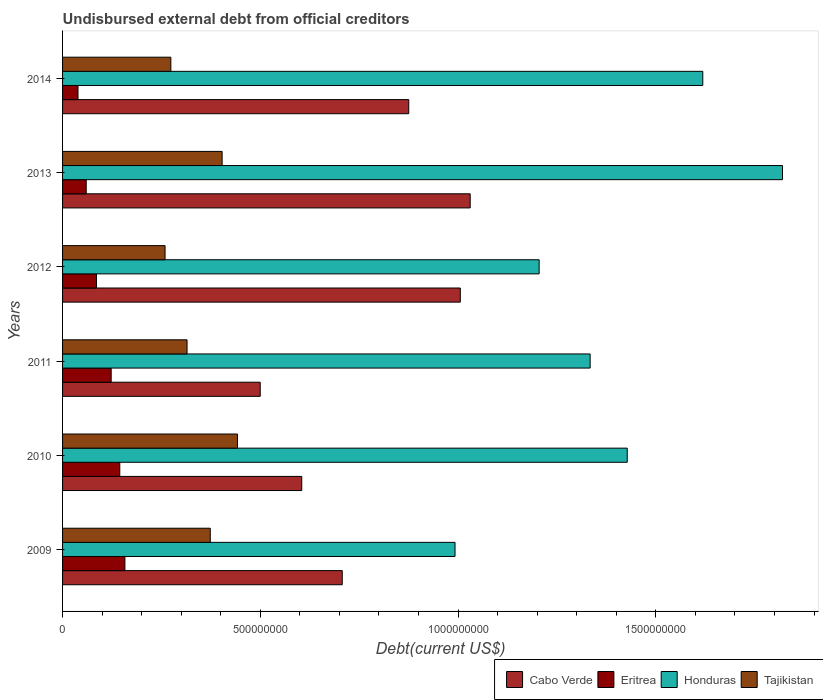Are the number of bars on each tick of the Y-axis equal?
Your response must be concise. Yes. How many bars are there on the 6th tick from the bottom?
Provide a short and direct response. 4. What is the label of the 4th group of bars from the top?
Keep it short and to the point. 2011. In how many cases, is the number of bars for a given year not equal to the number of legend labels?
Ensure brevity in your answer.  0. What is the total debt in Tajikistan in 2010?
Ensure brevity in your answer.  4.42e+08. Across all years, what is the maximum total debt in Cabo Verde?
Ensure brevity in your answer.  1.03e+09. Across all years, what is the minimum total debt in Eritrea?
Make the answer very short. 3.90e+07. In which year was the total debt in Eritrea maximum?
Give a very brief answer. 2009. In which year was the total debt in Cabo Verde minimum?
Offer a terse response. 2011. What is the total total debt in Honduras in the graph?
Offer a terse response. 8.40e+09. What is the difference between the total debt in Eritrea in 2011 and that in 2013?
Provide a short and direct response. 6.31e+07. What is the difference between the total debt in Eritrea in 2014 and the total debt in Tajikistan in 2012?
Your response must be concise. -2.20e+08. What is the average total debt in Eritrea per year?
Your answer should be very brief. 1.02e+08. In the year 2012, what is the difference between the total debt in Cabo Verde and total debt in Eritrea?
Ensure brevity in your answer.  9.20e+08. What is the ratio of the total debt in Eritrea in 2009 to that in 2012?
Provide a succinct answer. 1.84. Is the difference between the total debt in Cabo Verde in 2009 and 2011 greater than the difference between the total debt in Eritrea in 2009 and 2011?
Offer a terse response. Yes. What is the difference between the highest and the second highest total debt in Cabo Verde?
Your response must be concise. 2.50e+07. What is the difference between the highest and the lowest total debt in Honduras?
Make the answer very short. 8.28e+08. Is the sum of the total debt in Cabo Verde in 2010 and 2013 greater than the maximum total debt in Tajikistan across all years?
Ensure brevity in your answer.  Yes. Is it the case that in every year, the sum of the total debt in Eritrea and total debt in Honduras is greater than the sum of total debt in Tajikistan and total debt in Cabo Verde?
Keep it short and to the point. Yes. What does the 3rd bar from the top in 2011 represents?
Your response must be concise. Eritrea. What does the 4th bar from the bottom in 2011 represents?
Your answer should be very brief. Tajikistan. Is it the case that in every year, the sum of the total debt in Tajikistan and total debt in Eritrea is greater than the total debt in Honduras?
Keep it short and to the point. No. How many bars are there?
Provide a short and direct response. 24. Are all the bars in the graph horizontal?
Your answer should be very brief. Yes. Are the values on the major ticks of X-axis written in scientific E-notation?
Offer a terse response. No. Where does the legend appear in the graph?
Your response must be concise. Bottom right. How many legend labels are there?
Ensure brevity in your answer.  4. What is the title of the graph?
Offer a terse response. Undisbursed external debt from official creditors. What is the label or title of the X-axis?
Offer a terse response. Debt(current US$). What is the Debt(current US$) of Cabo Verde in 2009?
Your answer should be very brief. 7.07e+08. What is the Debt(current US$) of Eritrea in 2009?
Offer a very short reply. 1.58e+08. What is the Debt(current US$) of Honduras in 2009?
Keep it short and to the point. 9.92e+08. What is the Debt(current US$) of Tajikistan in 2009?
Make the answer very short. 3.73e+08. What is the Debt(current US$) of Cabo Verde in 2010?
Keep it short and to the point. 6.05e+08. What is the Debt(current US$) of Eritrea in 2010?
Provide a short and direct response. 1.45e+08. What is the Debt(current US$) in Honduras in 2010?
Provide a short and direct response. 1.43e+09. What is the Debt(current US$) in Tajikistan in 2010?
Make the answer very short. 4.42e+08. What is the Debt(current US$) of Cabo Verde in 2011?
Keep it short and to the point. 5.00e+08. What is the Debt(current US$) in Eritrea in 2011?
Your answer should be compact. 1.23e+08. What is the Debt(current US$) in Honduras in 2011?
Keep it short and to the point. 1.33e+09. What is the Debt(current US$) in Tajikistan in 2011?
Your response must be concise. 3.15e+08. What is the Debt(current US$) of Cabo Verde in 2012?
Your answer should be compact. 1.01e+09. What is the Debt(current US$) in Eritrea in 2012?
Provide a short and direct response. 8.58e+07. What is the Debt(current US$) in Honduras in 2012?
Your answer should be compact. 1.20e+09. What is the Debt(current US$) in Tajikistan in 2012?
Give a very brief answer. 2.59e+08. What is the Debt(current US$) of Cabo Verde in 2013?
Offer a very short reply. 1.03e+09. What is the Debt(current US$) of Eritrea in 2013?
Your answer should be compact. 5.98e+07. What is the Debt(current US$) of Honduras in 2013?
Your response must be concise. 1.82e+09. What is the Debt(current US$) of Tajikistan in 2013?
Give a very brief answer. 4.03e+08. What is the Debt(current US$) in Cabo Verde in 2014?
Ensure brevity in your answer.  8.75e+08. What is the Debt(current US$) of Eritrea in 2014?
Your answer should be compact. 3.90e+07. What is the Debt(current US$) in Honduras in 2014?
Give a very brief answer. 1.62e+09. What is the Debt(current US$) in Tajikistan in 2014?
Offer a very short reply. 2.74e+08. Across all years, what is the maximum Debt(current US$) in Cabo Verde?
Provide a short and direct response. 1.03e+09. Across all years, what is the maximum Debt(current US$) in Eritrea?
Ensure brevity in your answer.  1.58e+08. Across all years, what is the maximum Debt(current US$) of Honduras?
Provide a succinct answer. 1.82e+09. Across all years, what is the maximum Debt(current US$) in Tajikistan?
Make the answer very short. 4.42e+08. Across all years, what is the minimum Debt(current US$) in Cabo Verde?
Offer a very short reply. 5.00e+08. Across all years, what is the minimum Debt(current US$) in Eritrea?
Offer a very short reply. 3.90e+07. Across all years, what is the minimum Debt(current US$) of Honduras?
Ensure brevity in your answer.  9.92e+08. Across all years, what is the minimum Debt(current US$) in Tajikistan?
Provide a short and direct response. 2.59e+08. What is the total Debt(current US$) of Cabo Verde in the graph?
Your answer should be compact. 4.72e+09. What is the total Debt(current US$) in Eritrea in the graph?
Your response must be concise. 6.10e+08. What is the total Debt(current US$) of Honduras in the graph?
Keep it short and to the point. 8.40e+09. What is the total Debt(current US$) in Tajikistan in the graph?
Provide a succinct answer. 2.07e+09. What is the difference between the Debt(current US$) in Cabo Verde in 2009 and that in 2010?
Keep it short and to the point. 1.02e+08. What is the difference between the Debt(current US$) in Eritrea in 2009 and that in 2010?
Ensure brevity in your answer.  1.29e+07. What is the difference between the Debt(current US$) of Honduras in 2009 and that in 2010?
Your answer should be compact. -4.35e+08. What is the difference between the Debt(current US$) in Tajikistan in 2009 and that in 2010?
Your answer should be compact. -6.88e+07. What is the difference between the Debt(current US$) in Cabo Verde in 2009 and that in 2011?
Your answer should be very brief. 2.07e+08. What is the difference between the Debt(current US$) in Eritrea in 2009 and that in 2011?
Ensure brevity in your answer.  3.47e+07. What is the difference between the Debt(current US$) of Honduras in 2009 and that in 2011?
Ensure brevity in your answer.  -3.42e+08. What is the difference between the Debt(current US$) of Tajikistan in 2009 and that in 2011?
Ensure brevity in your answer.  5.87e+07. What is the difference between the Debt(current US$) of Cabo Verde in 2009 and that in 2012?
Offer a terse response. -2.99e+08. What is the difference between the Debt(current US$) in Eritrea in 2009 and that in 2012?
Keep it short and to the point. 7.18e+07. What is the difference between the Debt(current US$) of Honduras in 2009 and that in 2012?
Provide a succinct answer. -2.13e+08. What is the difference between the Debt(current US$) of Tajikistan in 2009 and that in 2012?
Ensure brevity in your answer.  1.14e+08. What is the difference between the Debt(current US$) of Cabo Verde in 2009 and that in 2013?
Offer a terse response. -3.23e+08. What is the difference between the Debt(current US$) of Eritrea in 2009 and that in 2013?
Keep it short and to the point. 9.78e+07. What is the difference between the Debt(current US$) in Honduras in 2009 and that in 2013?
Your answer should be compact. -8.28e+08. What is the difference between the Debt(current US$) in Tajikistan in 2009 and that in 2013?
Make the answer very short. -3.00e+07. What is the difference between the Debt(current US$) in Cabo Verde in 2009 and that in 2014?
Make the answer very short. -1.68e+08. What is the difference between the Debt(current US$) of Eritrea in 2009 and that in 2014?
Offer a very short reply. 1.19e+08. What is the difference between the Debt(current US$) of Honduras in 2009 and that in 2014?
Ensure brevity in your answer.  -6.26e+08. What is the difference between the Debt(current US$) in Tajikistan in 2009 and that in 2014?
Make the answer very short. 9.97e+07. What is the difference between the Debt(current US$) in Cabo Verde in 2010 and that in 2011?
Offer a terse response. 1.05e+08. What is the difference between the Debt(current US$) of Eritrea in 2010 and that in 2011?
Your answer should be very brief. 2.18e+07. What is the difference between the Debt(current US$) in Honduras in 2010 and that in 2011?
Your answer should be very brief. 9.38e+07. What is the difference between the Debt(current US$) of Tajikistan in 2010 and that in 2011?
Offer a terse response. 1.27e+08. What is the difference between the Debt(current US$) in Cabo Verde in 2010 and that in 2012?
Your answer should be compact. -4.01e+08. What is the difference between the Debt(current US$) in Eritrea in 2010 and that in 2012?
Give a very brief answer. 5.89e+07. What is the difference between the Debt(current US$) of Honduras in 2010 and that in 2012?
Your answer should be compact. 2.23e+08. What is the difference between the Debt(current US$) of Tajikistan in 2010 and that in 2012?
Your response must be concise. 1.83e+08. What is the difference between the Debt(current US$) in Cabo Verde in 2010 and that in 2013?
Offer a terse response. -4.26e+08. What is the difference between the Debt(current US$) in Eritrea in 2010 and that in 2013?
Offer a very short reply. 8.49e+07. What is the difference between the Debt(current US$) in Honduras in 2010 and that in 2013?
Give a very brief answer. -3.93e+08. What is the difference between the Debt(current US$) of Tajikistan in 2010 and that in 2013?
Your answer should be very brief. 3.88e+07. What is the difference between the Debt(current US$) of Cabo Verde in 2010 and that in 2014?
Your answer should be very brief. -2.71e+08. What is the difference between the Debt(current US$) of Eritrea in 2010 and that in 2014?
Give a very brief answer. 1.06e+08. What is the difference between the Debt(current US$) in Honduras in 2010 and that in 2014?
Keep it short and to the point. -1.91e+08. What is the difference between the Debt(current US$) in Tajikistan in 2010 and that in 2014?
Make the answer very short. 1.68e+08. What is the difference between the Debt(current US$) in Cabo Verde in 2011 and that in 2012?
Offer a very short reply. -5.06e+08. What is the difference between the Debt(current US$) in Eritrea in 2011 and that in 2012?
Offer a very short reply. 3.71e+07. What is the difference between the Debt(current US$) of Honduras in 2011 and that in 2012?
Keep it short and to the point. 1.29e+08. What is the difference between the Debt(current US$) in Tajikistan in 2011 and that in 2012?
Offer a very short reply. 5.56e+07. What is the difference between the Debt(current US$) in Cabo Verde in 2011 and that in 2013?
Keep it short and to the point. -5.31e+08. What is the difference between the Debt(current US$) of Eritrea in 2011 and that in 2013?
Ensure brevity in your answer.  6.31e+07. What is the difference between the Debt(current US$) in Honduras in 2011 and that in 2013?
Provide a short and direct response. -4.86e+08. What is the difference between the Debt(current US$) of Tajikistan in 2011 and that in 2013?
Keep it short and to the point. -8.87e+07. What is the difference between the Debt(current US$) in Cabo Verde in 2011 and that in 2014?
Provide a succinct answer. -3.76e+08. What is the difference between the Debt(current US$) of Eritrea in 2011 and that in 2014?
Offer a very short reply. 8.38e+07. What is the difference between the Debt(current US$) in Honduras in 2011 and that in 2014?
Provide a short and direct response. -2.85e+08. What is the difference between the Debt(current US$) in Tajikistan in 2011 and that in 2014?
Your answer should be compact. 4.10e+07. What is the difference between the Debt(current US$) in Cabo Verde in 2012 and that in 2013?
Keep it short and to the point. -2.50e+07. What is the difference between the Debt(current US$) in Eritrea in 2012 and that in 2013?
Keep it short and to the point. 2.60e+07. What is the difference between the Debt(current US$) in Honduras in 2012 and that in 2013?
Provide a short and direct response. -6.15e+08. What is the difference between the Debt(current US$) of Tajikistan in 2012 and that in 2013?
Provide a succinct answer. -1.44e+08. What is the difference between the Debt(current US$) of Cabo Verde in 2012 and that in 2014?
Make the answer very short. 1.30e+08. What is the difference between the Debt(current US$) in Eritrea in 2012 and that in 2014?
Your response must be concise. 4.68e+07. What is the difference between the Debt(current US$) of Honduras in 2012 and that in 2014?
Your answer should be very brief. -4.14e+08. What is the difference between the Debt(current US$) in Tajikistan in 2012 and that in 2014?
Provide a succinct answer. -1.46e+07. What is the difference between the Debt(current US$) in Cabo Verde in 2013 and that in 2014?
Offer a terse response. 1.55e+08. What is the difference between the Debt(current US$) of Eritrea in 2013 and that in 2014?
Your response must be concise. 2.08e+07. What is the difference between the Debt(current US$) of Honduras in 2013 and that in 2014?
Your response must be concise. 2.02e+08. What is the difference between the Debt(current US$) of Tajikistan in 2013 and that in 2014?
Keep it short and to the point. 1.30e+08. What is the difference between the Debt(current US$) of Cabo Verde in 2009 and the Debt(current US$) of Eritrea in 2010?
Make the answer very short. 5.62e+08. What is the difference between the Debt(current US$) of Cabo Verde in 2009 and the Debt(current US$) of Honduras in 2010?
Your response must be concise. -7.21e+08. What is the difference between the Debt(current US$) in Cabo Verde in 2009 and the Debt(current US$) in Tajikistan in 2010?
Provide a short and direct response. 2.65e+08. What is the difference between the Debt(current US$) of Eritrea in 2009 and the Debt(current US$) of Honduras in 2010?
Provide a short and direct response. -1.27e+09. What is the difference between the Debt(current US$) in Eritrea in 2009 and the Debt(current US$) in Tajikistan in 2010?
Offer a terse response. -2.85e+08. What is the difference between the Debt(current US$) of Honduras in 2009 and the Debt(current US$) of Tajikistan in 2010?
Your answer should be very brief. 5.50e+08. What is the difference between the Debt(current US$) in Cabo Verde in 2009 and the Debt(current US$) in Eritrea in 2011?
Ensure brevity in your answer.  5.84e+08. What is the difference between the Debt(current US$) in Cabo Verde in 2009 and the Debt(current US$) in Honduras in 2011?
Offer a terse response. -6.27e+08. What is the difference between the Debt(current US$) in Cabo Verde in 2009 and the Debt(current US$) in Tajikistan in 2011?
Offer a terse response. 3.92e+08. What is the difference between the Debt(current US$) of Eritrea in 2009 and the Debt(current US$) of Honduras in 2011?
Give a very brief answer. -1.18e+09. What is the difference between the Debt(current US$) of Eritrea in 2009 and the Debt(current US$) of Tajikistan in 2011?
Your answer should be compact. -1.57e+08. What is the difference between the Debt(current US$) in Honduras in 2009 and the Debt(current US$) in Tajikistan in 2011?
Your answer should be compact. 6.78e+08. What is the difference between the Debt(current US$) of Cabo Verde in 2009 and the Debt(current US$) of Eritrea in 2012?
Ensure brevity in your answer.  6.21e+08. What is the difference between the Debt(current US$) of Cabo Verde in 2009 and the Debt(current US$) of Honduras in 2012?
Ensure brevity in your answer.  -4.98e+08. What is the difference between the Debt(current US$) in Cabo Verde in 2009 and the Debt(current US$) in Tajikistan in 2012?
Offer a terse response. 4.48e+08. What is the difference between the Debt(current US$) of Eritrea in 2009 and the Debt(current US$) of Honduras in 2012?
Offer a very short reply. -1.05e+09. What is the difference between the Debt(current US$) of Eritrea in 2009 and the Debt(current US$) of Tajikistan in 2012?
Your response must be concise. -1.02e+08. What is the difference between the Debt(current US$) in Honduras in 2009 and the Debt(current US$) in Tajikistan in 2012?
Make the answer very short. 7.33e+08. What is the difference between the Debt(current US$) of Cabo Verde in 2009 and the Debt(current US$) of Eritrea in 2013?
Your response must be concise. 6.47e+08. What is the difference between the Debt(current US$) of Cabo Verde in 2009 and the Debt(current US$) of Honduras in 2013?
Your answer should be compact. -1.11e+09. What is the difference between the Debt(current US$) of Cabo Verde in 2009 and the Debt(current US$) of Tajikistan in 2013?
Give a very brief answer. 3.04e+08. What is the difference between the Debt(current US$) of Eritrea in 2009 and the Debt(current US$) of Honduras in 2013?
Give a very brief answer. -1.66e+09. What is the difference between the Debt(current US$) of Eritrea in 2009 and the Debt(current US$) of Tajikistan in 2013?
Give a very brief answer. -2.46e+08. What is the difference between the Debt(current US$) of Honduras in 2009 and the Debt(current US$) of Tajikistan in 2013?
Offer a terse response. 5.89e+08. What is the difference between the Debt(current US$) in Cabo Verde in 2009 and the Debt(current US$) in Eritrea in 2014?
Your answer should be compact. 6.68e+08. What is the difference between the Debt(current US$) of Cabo Verde in 2009 and the Debt(current US$) of Honduras in 2014?
Ensure brevity in your answer.  -9.12e+08. What is the difference between the Debt(current US$) in Cabo Verde in 2009 and the Debt(current US$) in Tajikistan in 2014?
Offer a terse response. 4.33e+08. What is the difference between the Debt(current US$) in Eritrea in 2009 and the Debt(current US$) in Honduras in 2014?
Your answer should be very brief. -1.46e+09. What is the difference between the Debt(current US$) in Eritrea in 2009 and the Debt(current US$) in Tajikistan in 2014?
Give a very brief answer. -1.16e+08. What is the difference between the Debt(current US$) of Honduras in 2009 and the Debt(current US$) of Tajikistan in 2014?
Give a very brief answer. 7.19e+08. What is the difference between the Debt(current US$) of Cabo Verde in 2010 and the Debt(current US$) of Eritrea in 2011?
Offer a terse response. 4.82e+08. What is the difference between the Debt(current US$) in Cabo Verde in 2010 and the Debt(current US$) in Honduras in 2011?
Your response must be concise. -7.29e+08. What is the difference between the Debt(current US$) of Cabo Verde in 2010 and the Debt(current US$) of Tajikistan in 2011?
Offer a very short reply. 2.90e+08. What is the difference between the Debt(current US$) in Eritrea in 2010 and the Debt(current US$) in Honduras in 2011?
Provide a succinct answer. -1.19e+09. What is the difference between the Debt(current US$) of Eritrea in 2010 and the Debt(current US$) of Tajikistan in 2011?
Your answer should be compact. -1.70e+08. What is the difference between the Debt(current US$) of Honduras in 2010 and the Debt(current US$) of Tajikistan in 2011?
Make the answer very short. 1.11e+09. What is the difference between the Debt(current US$) of Cabo Verde in 2010 and the Debt(current US$) of Eritrea in 2012?
Offer a very short reply. 5.19e+08. What is the difference between the Debt(current US$) of Cabo Verde in 2010 and the Debt(current US$) of Honduras in 2012?
Ensure brevity in your answer.  -6.00e+08. What is the difference between the Debt(current US$) of Cabo Verde in 2010 and the Debt(current US$) of Tajikistan in 2012?
Offer a terse response. 3.46e+08. What is the difference between the Debt(current US$) of Eritrea in 2010 and the Debt(current US$) of Honduras in 2012?
Give a very brief answer. -1.06e+09. What is the difference between the Debt(current US$) in Eritrea in 2010 and the Debt(current US$) in Tajikistan in 2012?
Offer a terse response. -1.14e+08. What is the difference between the Debt(current US$) in Honduras in 2010 and the Debt(current US$) in Tajikistan in 2012?
Keep it short and to the point. 1.17e+09. What is the difference between the Debt(current US$) of Cabo Verde in 2010 and the Debt(current US$) of Eritrea in 2013?
Make the answer very short. 5.45e+08. What is the difference between the Debt(current US$) of Cabo Verde in 2010 and the Debt(current US$) of Honduras in 2013?
Make the answer very short. -1.22e+09. What is the difference between the Debt(current US$) of Cabo Verde in 2010 and the Debt(current US$) of Tajikistan in 2013?
Your answer should be compact. 2.01e+08. What is the difference between the Debt(current US$) of Eritrea in 2010 and the Debt(current US$) of Honduras in 2013?
Provide a succinct answer. -1.68e+09. What is the difference between the Debt(current US$) in Eritrea in 2010 and the Debt(current US$) in Tajikistan in 2013?
Offer a terse response. -2.59e+08. What is the difference between the Debt(current US$) in Honduras in 2010 and the Debt(current US$) in Tajikistan in 2013?
Offer a terse response. 1.02e+09. What is the difference between the Debt(current US$) of Cabo Verde in 2010 and the Debt(current US$) of Eritrea in 2014?
Make the answer very short. 5.66e+08. What is the difference between the Debt(current US$) of Cabo Verde in 2010 and the Debt(current US$) of Honduras in 2014?
Provide a short and direct response. -1.01e+09. What is the difference between the Debt(current US$) in Cabo Verde in 2010 and the Debt(current US$) in Tajikistan in 2014?
Ensure brevity in your answer.  3.31e+08. What is the difference between the Debt(current US$) in Eritrea in 2010 and the Debt(current US$) in Honduras in 2014?
Ensure brevity in your answer.  -1.47e+09. What is the difference between the Debt(current US$) in Eritrea in 2010 and the Debt(current US$) in Tajikistan in 2014?
Ensure brevity in your answer.  -1.29e+08. What is the difference between the Debt(current US$) in Honduras in 2010 and the Debt(current US$) in Tajikistan in 2014?
Offer a very short reply. 1.15e+09. What is the difference between the Debt(current US$) in Cabo Verde in 2011 and the Debt(current US$) in Eritrea in 2012?
Offer a terse response. 4.14e+08. What is the difference between the Debt(current US$) in Cabo Verde in 2011 and the Debt(current US$) in Honduras in 2012?
Offer a very short reply. -7.05e+08. What is the difference between the Debt(current US$) in Cabo Verde in 2011 and the Debt(current US$) in Tajikistan in 2012?
Offer a terse response. 2.41e+08. What is the difference between the Debt(current US$) of Eritrea in 2011 and the Debt(current US$) of Honduras in 2012?
Offer a very short reply. -1.08e+09. What is the difference between the Debt(current US$) of Eritrea in 2011 and the Debt(current US$) of Tajikistan in 2012?
Your response must be concise. -1.36e+08. What is the difference between the Debt(current US$) in Honduras in 2011 and the Debt(current US$) in Tajikistan in 2012?
Provide a short and direct response. 1.07e+09. What is the difference between the Debt(current US$) of Cabo Verde in 2011 and the Debt(current US$) of Eritrea in 2013?
Provide a short and direct response. 4.40e+08. What is the difference between the Debt(current US$) of Cabo Verde in 2011 and the Debt(current US$) of Honduras in 2013?
Provide a short and direct response. -1.32e+09. What is the difference between the Debt(current US$) in Cabo Verde in 2011 and the Debt(current US$) in Tajikistan in 2013?
Ensure brevity in your answer.  9.63e+07. What is the difference between the Debt(current US$) of Eritrea in 2011 and the Debt(current US$) of Honduras in 2013?
Provide a short and direct response. -1.70e+09. What is the difference between the Debt(current US$) in Eritrea in 2011 and the Debt(current US$) in Tajikistan in 2013?
Provide a succinct answer. -2.81e+08. What is the difference between the Debt(current US$) of Honduras in 2011 and the Debt(current US$) of Tajikistan in 2013?
Offer a very short reply. 9.30e+08. What is the difference between the Debt(current US$) in Cabo Verde in 2011 and the Debt(current US$) in Eritrea in 2014?
Offer a very short reply. 4.61e+08. What is the difference between the Debt(current US$) of Cabo Verde in 2011 and the Debt(current US$) of Honduras in 2014?
Provide a succinct answer. -1.12e+09. What is the difference between the Debt(current US$) of Cabo Verde in 2011 and the Debt(current US$) of Tajikistan in 2014?
Give a very brief answer. 2.26e+08. What is the difference between the Debt(current US$) in Eritrea in 2011 and the Debt(current US$) in Honduras in 2014?
Keep it short and to the point. -1.50e+09. What is the difference between the Debt(current US$) of Eritrea in 2011 and the Debt(current US$) of Tajikistan in 2014?
Offer a very short reply. -1.51e+08. What is the difference between the Debt(current US$) of Honduras in 2011 and the Debt(current US$) of Tajikistan in 2014?
Your answer should be very brief. 1.06e+09. What is the difference between the Debt(current US$) of Cabo Verde in 2012 and the Debt(current US$) of Eritrea in 2013?
Your answer should be very brief. 9.46e+08. What is the difference between the Debt(current US$) in Cabo Verde in 2012 and the Debt(current US$) in Honduras in 2013?
Make the answer very short. -8.15e+08. What is the difference between the Debt(current US$) of Cabo Verde in 2012 and the Debt(current US$) of Tajikistan in 2013?
Your response must be concise. 6.02e+08. What is the difference between the Debt(current US$) of Eritrea in 2012 and the Debt(current US$) of Honduras in 2013?
Your answer should be very brief. -1.73e+09. What is the difference between the Debt(current US$) of Eritrea in 2012 and the Debt(current US$) of Tajikistan in 2013?
Your answer should be very brief. -3.18e+08. What is the difference between the Debt(current US$) of Honduras in 2012 and the Debt(current US$) of Tajikistan in 2013?
Make the answer very short. 8.02e+08. What is the difference between the Debt(current US$) of Cabo Verde in 2012 and the Debt(current US$) of Eritrea in 2014?
Keep it short and to the point. 9.67e+08. What is the difference between the Debt(current US$) in Cabo Verde in 2012 and the Debt(current US$) in Honduras in 2014?
Offer a terse response. -6.13e+08. What is the difference between the Debt(current US$) of Cabo Verde in 2012 and the Debt(current US$) of Tajikistan in 2014?
Offer a terse response. 7.32e+08. What is the difference between the Debt(current US$) of Eritrea in 2012 and the Debt(current US$) of Honduras in 2014?
Offer a very short reply. -1.53e+09. What is the difference between the Debt(current US$) of Eritrea in 2012 and the Debt(current US$) of Tajikistan in 2014?
Offer a terse response. -1.88e+08. What is the difference between the Debt(current US$) in Honduras in 2012 and the Debt(current US$) in Tajikistan in 2014?
Your answer should be compact. 9.31e+08. What is the difference between the Debt(current US$) of Cabo Verde in 2013 and the Debt(current US$) of Eritrea in 2014?
Keep it short and to the point. 9.92e+08. What is the difference between the Debt(current US$) in Cabo Verde in 2013 and the Debt(current US$) in Honduras in 2014?
Ensure brevity in your answer.  -5.88e+08. What is the difference between the Debt(current US$) in Cabo Verde in 2013 and the Debt(current US$) in Tajikistan in 2014?
Provide a succinct answer. 7.57e+08. What is the difference between the Debt(current US$) of Eritrea in 2013 and the Debt(current US$) of Honduras in 2014?
Make the answer very short. -1.56e+09. What is the difference between the Debt(current US$) of Eritrea in 2013 and the Debt(current US$) of Tajikistan in 2014?
Provide a short and direct response. -2.14e+08. What is the difference between the Debt(current US$) of Honduras in 2013 and the Debt(current US$) of Tajikistan in 2014?
Provide a short and direct response. 1.55e+09. What is the average Debt(current US$) in Cabo Verde per year?
Provide a succinct answer. 7.87e+08. What is the average Debt(current US$) in Eritrea per year?
Give a very brief answer. 1.02e+08. What is the average Debt(current US$) in Honduras per year?
Provide a short and direct response. 1.40e+09. What is the average Debt(current US$) in Tajikistan per year?
Your response must be concise. 3.44e+08. In the year 2009, what is the difference between the Debt(current US$) of Cabo Verde and Debt(current US$) of Eritrea?
Offer a terse response. 5.50e+08. In the year 2009, what is the difference between the Debt(current US$) of Cabo Verde and Debt(current US$) of Honduras?
Your response must be concise. -2.85e+08. In the year 2009, what is the difference between the Debt(current US$) of Cabo Verde and Debt(current US$) of Tajikistan?
Keep it short and to the point. 3.34e+08. In the year 2009, what is the difference between the Debt(current US$) of Eritrea and Debt(current US$) of Honduras?
Your answer should be very brief. -8.35e+08. In the year 2009, what is the difference between the Debt(current US$) in Eritrea and Debt(current US$) in Tajikistan?
Give a very brief answer. -2.16e+08. In the year 2009, what is the difference between the Debt(current US$) in Honduras and Debt(current US$) in Tajikistan?
Keep it short and to the point. 6.19e+08. In the year 2010, what is the difference between the Debt(current US$) of Cabo Verde and Debt(current US$) of Eritrea?
Offer a terse response. 4.60e+08. In the year 2010, what is the difference between the Debt(current US$) of Cabo Verde and Debt(current US$) of Honduras?
Ensure brevity in your answer.  -8.23e+08. In the year 2010, what is the difference between the Debt(current US$) of Cabo Verde and Debt(current US$) of Tajikistan?
Your response must be concise. 1.63e+08. In the year 2010, what is the difference between the Debt(current US$) in Eritrea and Debt(current US$) in Honduras?
Offer a very short reply. -1.28e+09. In the year 2010, what is the difference between the Debt(current US$) in Eritrea and Debt(current US$) in Tajikistan?
Give a very brief answer. -2.98e+08. In the year 2010, what is the difference between the Debt(current US$) of Honduras and Debt(current US$) of Tajikistan?
Your response must be concise. 9.85e+08. In the year 2011, what is the difference between the Debt(current US$) of Cabo Verde and Debt(current US$) of Eritrea?
Keep it short and to the point. 3.77e+08. In the year 2011, what is the difference between the Debt(current US$) in Cabo Verde and Debt(current US$) in Honduras?
Your answer should be compact. -8.34e+08. In the year 2011, what is the difference between the Debt(current US$) in Cabo Verde and Debt(current US$) in Tajikistan?
Keep it short and to the point. 1.85e+08. In the year 2011, what is the difference between the Debt(current US$) in Eritrea and Debt(current US$) in Honduras?
Your answer should be very brief. -1.21e+09. In the year 2011, what is the difference between the Debt(current US$) in Eritrea and Debt(current US$) in Tajikistan?
Offer a terse response. -1.92e+08. In the year 2011, what is the difference between the Debt(current US$) of Honduras and Debt(current US$) of Tajikistan?
Make the answer very short. 1.02e+09. In the year 2012, what is the difference between the Debt(current US$) in Cabo Verde and Debt(current US$) in Eritrea?
Your response must be concise. 9.20e+08. In the year 2012, what is the difference between the Debt(current US$) in Cabo Verde and Debt(current US$) in Honduras?
Offer a terse response. -1.99e+08. In the year 2012, what is the difference between the Debt(current US$) in Cabo Verde and Debt(current US$) in Tajikistan?
Provide a short and direct response. 7.47e+08. In the year 2012, what is the difference between the Debt(current US$) in Eritrea and Debt(current US$) in Honduras?
Provide a short and direct response. -1.12e+09. In the year 2012, what is the difference between the Debt(current US$) of Eritrea and Debt(current US$) of Tajikistan?
Keep it short and to the point. -1.73e+08. In the year 2012, what is the difference between the Debt(current US$) in Honduras and Debt(current US$) in Tajikistan?
Your answer should be very brief. 9.46e+08. In the year 2013, what is the difference between the Debt(current US$) of Cabo Verde and Debt(current US$) of Eritrea?
Ensure brevity in your answer.  9.71e+08. In the year 2013, what is the difference between the Debt(current US$) of Cabo Verde and Debt(current US$) of Honduras?
Offer a terse response. -7.90e+08. In the year 2013, what is the difference between the Debt(current US$) of Cabo Verde and Debt(current US$) of Tajikistan?
Make the answer very short. 6.27e+08. In the year 2013, what is the difference between the Debt(current US$) in Eritrea and Debt(current US$) in Honduras?
Ensure brevity in your answer.  -1.76e+09. In the year 2013, what is the difference between the Debt(current US$) of Eritrea and Debt(current US$) of Tajikistan?
Your answer should be compact. -3.44e+08. In the year 2013, what is the difference between the Debt(current US$) in Honduras and Debt(current US$) in Tajikistan?
Offer a very short reply. 1.42e+09. In the year 2014, what is the difference between the Debt(current US$) in Cabo Verde and Debt(current US$) in Eritrea?
Your response must be concise. 8.36e+08. In the year 2014, what is the difference between the Debt(current US$) in Cabo Verde and Debt(current US$) in Honduras?
Make the answer very short. -7.43e+08. In the year 2014, what is the difference between the Debt(current US$) in Cabo Verde and Debt(current US$) in Tajikistan?
Offer a terse response. 6.02e+08. In the year 2014, what is the difference between the Debt(current US$) of Eritrea and Debt(current US$) of Honduras?
Your response must be concise. -1.58e+09. In the year 2014, what is the difference between the Debt(current US$) in Eritrea and Debt(current US$) in Tajikistan?
Ensure brevity in your answer.  -2.35e+08. In the year 2014, what is the difference between the Debt(current US$) in Honduras and Debt(current US$) in Tajikistan?
Your response must be concise. 1.34e+09. What is the ratio of the Debt(current US$) in Cabo Verde in 2009 to that in 2010?
Provide a short and direct response. 1.17. What is the ratio of the Debt(current US$) in Eritrea in 2009 to that in 2010?
Make the answer very short. 1.09. What is the ratio of the Debt(current US$) in Honduras in 2009 to that in 2010?
Your response must be concise. 0.69. What is the ratio of the Debt(current US$) in Tajikistan in 2009 to that in 2010?
Offer a terse response. 0.84. What is the ratio of the Debt(current US$) in Cabo Verde in 2009 to that in 2011?
Your answer should be very brief. 1.42. What is the ratio of the Debt(current US$) of Eritrea in 2009 to that in 2011?
Your response must be concise. 1.28. What is the ratio of the Debt(current US$) of Honduras in 2009 to that in 2011?
Offer a very short reply. 0.74. What is the ratio of the Debt(current US$) in Tajikistan in 2009 to that in 2011?
Provide a short and direct response. 1.19. What is the ratio of the Debt(current US$) of Cabo Verde in 2009 to that in 2012?
Provide a short and direct response. 0.7. What is the ratio of the Debt(current US$) in Eritrea in 2009 to that in 2012?
Your answer should be compact. 1.84. What is the ratio of the Debt(current US$) in Honduras in 2009 to that in 2012?
Give a very brief answer. 0.82. What is the ratio of the Debt(current US$) in Tajikistan in 2009 to that in 2012?
Make the answer very short. 1.44. What is the ratio of the Debt(current US$) of Cabo Verde in 2009 to that in 2013?
Your answer should be compact. 0.69. What is the ratio of the Debt(current US$) in Eritrea in 2009 to that in 2013?
Give a very brief answer. 2.64. What is the ratio of the Debt(current US$) of Honduras in 2009 to that in 2013?
Keep it short and to the point. 0.55. What is the ratio of the Debt(current US$) in Tajikistan in 2009 to that in 2013?
Keep it short and to the point. 0.93. What is the ratio of the Debt(current US$) in Cabo Verde in 2009 to that in 2014?
Offer a very short reply. 0.81. What is the ratio of the Debt(current US$) of Eritrea in 2009 to that in 2014?
Make the answer very short. 4.04. What is the ratio of the Debt(current US$) in Honduras in 2009 to that in 2014?
Your response must be concise. 0.61. What is the ratio of the Debt(current US$) of Tajikistan in 2009 to that in 2014?
Offer a very short reply. 1.36. What is the ratio of the Debt(current US$) in Cabo Verde in 2010 to that in 2011?
Your response must be concise. 1.21. What is the ratio of the Debt(current US$) of Eritrea in 2010 to that in 2011?
Offer a terse response. 1.18. What is the ratio of the Debt(current US$) in Honduras in 2010 to that in 2011?
Offer a very short reply. 1.07. What is the ratio of the Debt(current US$) in Tajikistan in 2010 to that in 2011?
Offer a terse response. 1.41. What is the ratio of the Debt(current US$) of Cabo Verde in 2010 to that in 2012?
Your response must be concise. 0.6. What is the ratio of the Debt(current US$) in Eritrea in 2010 to that in 2012?
Keep it short and to the point. 1.69. What is the ratio of the Debt(current US$) of Honduras in 2010 to that in 2012?
Keep it short and to the point. 1.18. What is the ratio of the Debt(current US$) of Tajikistan in 2010 to that in 2012?
Keep it short and to the point. 1.71. What is the ratio of the Debt(current US$) of Cabo Verde in 2010 to that in 2013?
Your response must be concise. 0.59. What is the ratio of the Debt(current US$) of Eritrea in 2010 to that in 2013?
Your answer should be very brief. 2.42. What is the ratio of the Debt(current US$) of Honduras in 2010 to that in 2013?
Keep it short and to the point. 0.78. What is the ratio of the Debt(current US$) of Tajikistan in 2010 to that in 2013?
Ensure brevity in your answer.  1.1. What is the ratio of the Debt(current US$) of Cabo Verde in 2010 to that in 2014?
Your response must be concise. 0.69. What is the ratio of the Debt(current US$) in Eritrea in 2010 to that in 2014?
Offer a very short reply. 3.71. What is the ratio of the Debt(current US$) of Honduras in 2010 to that in 2014?
Make the answer very short. 0.88. What is the ratio of the Debt(current US$) of Tajikistan in 2010 to that in 2014?
Keep it short and to the point. 1.62. What is the ratio of the Debt(current US$) in Cabo Verde in 2011 to that in 2012?
Your answer should be compact. 0.5. What is the ratio of the Debt(current US$) of Eritrea in 2011 to that in 2012?
Offer a very short reply. 1.43. What is the ratio of the Debt(current US$) in Honduras in 2011 to that in 2012?
Your response must be concise. 1.11. What is the ratio of the Debt(current US$) in Tajikistan in 2011 to that in 2012?
Provide a short and direct response. 1.21. What is the ratio of the Debt(current US$) in Cabo Verde in 2011 to that in 2013?
Offer a terse response. 0.48. What is the ratio of the Debt(current US$) of Eritrea in 2011 to that in 2013?
Provide a short and direct response. 2.05. What is the ratio of the Debt(current US$) in Honduras in 2011 to that in 2013?
Give a very brief answer. 0.73. What is the ratio of the Debt(current US$) in Tajikistan in 2011 to that in 2013?
Offer a terse response. 0.78. What is the ratio of the Debt(current US$) in Cabo Verde in 2011 to that in 2014?
Provide a succinct answer. 0.57. What is the ratio of the Debt(current US$) of Eritrea in 2011 to that in 2014?
Offer a terse response. 3.15. What is the ratio of the Debt(current US$) of Honduras in 2011 to that in 2014?
Offer a terse response. 0.82. What is the ratio of the Debt(current US$) of Tajikistan in 2011 to that in 2014?
Ensure brevity in your answer.  1.15. What is the ratio of the Debt(current US$) in Cabo Verde in 2012 to that in 2013?
Keep it short and to the point. 0.98. What is the ratio of the Debt(current US$) of Eritrea in 2012 to that in 2013?
Make the answer very short. 1.43. What is the ratio of the Debt(current US$) in Honduras in 2012 to that in 2013?
Your answer should be very brief. 0.66. What is the ratio of the Debt(current US$) of Tajikistan in 2012 to that in 2013?
Keep it short and to the point. 0.64. What is the ratio of the Debt(current US$) of Cabo Verde in 2012 to that in 2014?
Your answer should be compact. 1.15. What is the ratio of the Debt(current US$) of Eritrea in 2012 to that in 2014?
Your answer should be very brief. 2.2. What is the ratio of the Debt(current US$) of Honduras in 2012 to that in 2014?
Your answer should be very brief. 0.74. What is the ratio of the Debt(current US$) in Tajikistan in 2012 to that in 2014?
Keep it short and to the point. 0.95. What is the ratio of the Debt(current US$) of Cabo Verde in 2013 to that in 2014?
Keep it short and to the point. 1.18. What is the ratio of the Debt(current US$) in Eritrea in 2013 to that in 2014?
Make the answer very short. 1.53. What is the ratio of the Debt(current US$) of Honduras in 2013 to that in 2014?
Your answer should be compact. 1.12. What is the ratio of the Debt(current US$) in Tajikistan in 2013 to that in 2014?
Offer a terse response. 1.47. What is the difference between the highest and the second highest Debt(current US$) of Cabo Verde?
Make the answer very short. 2.50e+07. What is the difference between the highest and the second highest Debt(current US$) in Eritrea?
Ensure brevity in your answer.  1.29e+07. What is the difference between the highest and the second highest Debt(current US$) of Honduras?
Your answer should be compact. 2.02e+08. What is the difference between the highest and the second highest Debt(current US$) of Tajikistan?
Give a very brief answer. 3.88e+07. What is the difference between the highest and the lowest Debt(current US$) of Cabo Verde?
Your response must be concise. 5.31e+08. What is the difference between the highest and the lowest Debt(current US$) of Eritrea?
Offer a very short reply. 1.19e+08. What is the difference between the highest and the lowest Debt(current US$) in Honduras?
Your answer should be compact. 8.28e+08. What is the difference between the highest and the lowest Debt(current US$) of Tajikistan?
Give a very brief answer. 1.83e+08. 